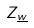<formula> <loc_0><loc_0><loc_500><loc_500>Z _ { \underline { w } }</formula> 